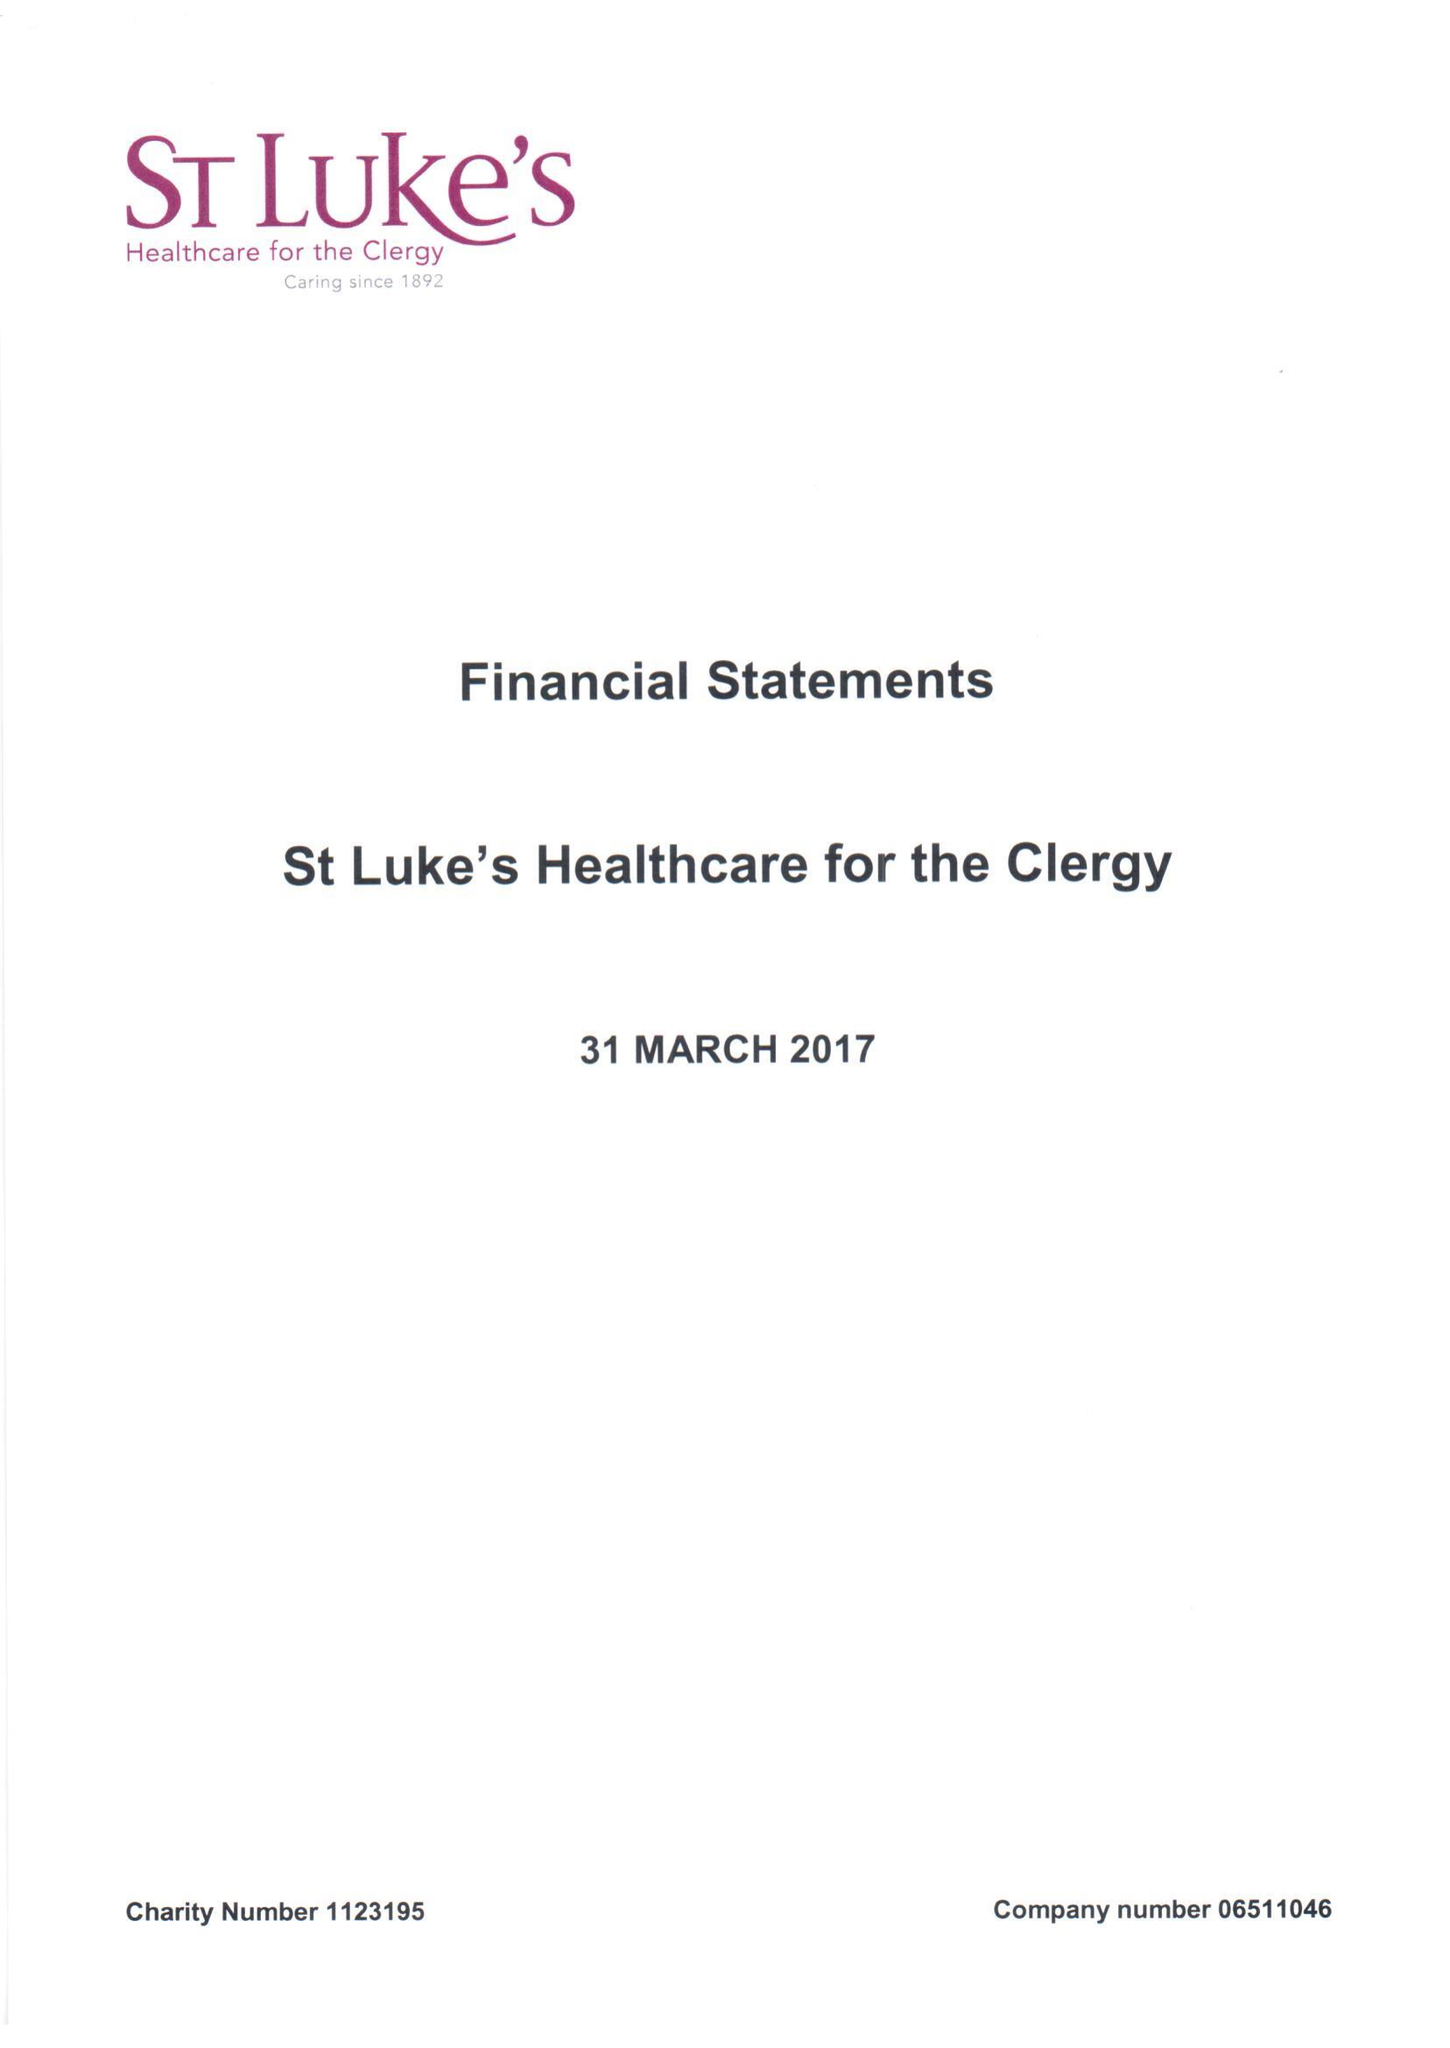What is the value for the address__street_line?
Answer the question using a single word or phrase. 27 GREAT SMITH STREET 